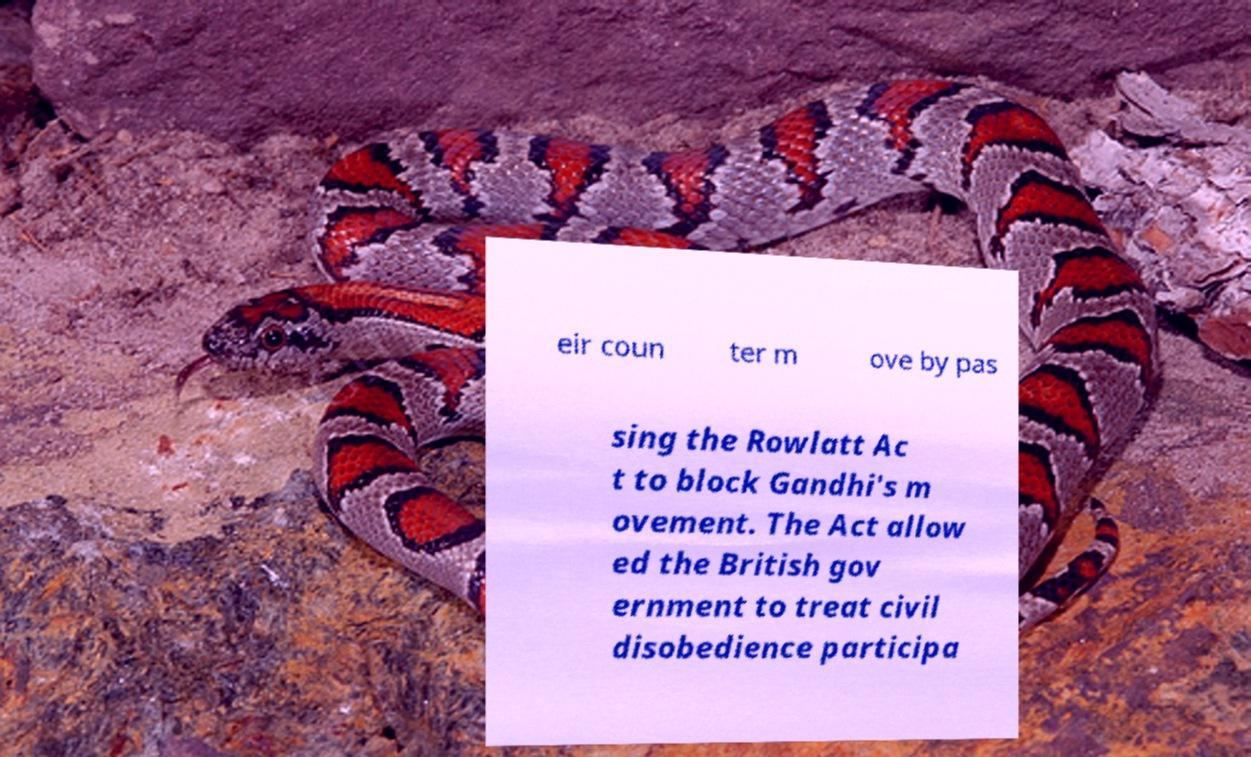I need the written content from this picture converted into text. Can you do that? eir coun ter m ove by pas sing the Rowlatt Ac t to block Gandhi's m ovement. The Act allow ed the British gov ernment to treat civil disobedience participa 